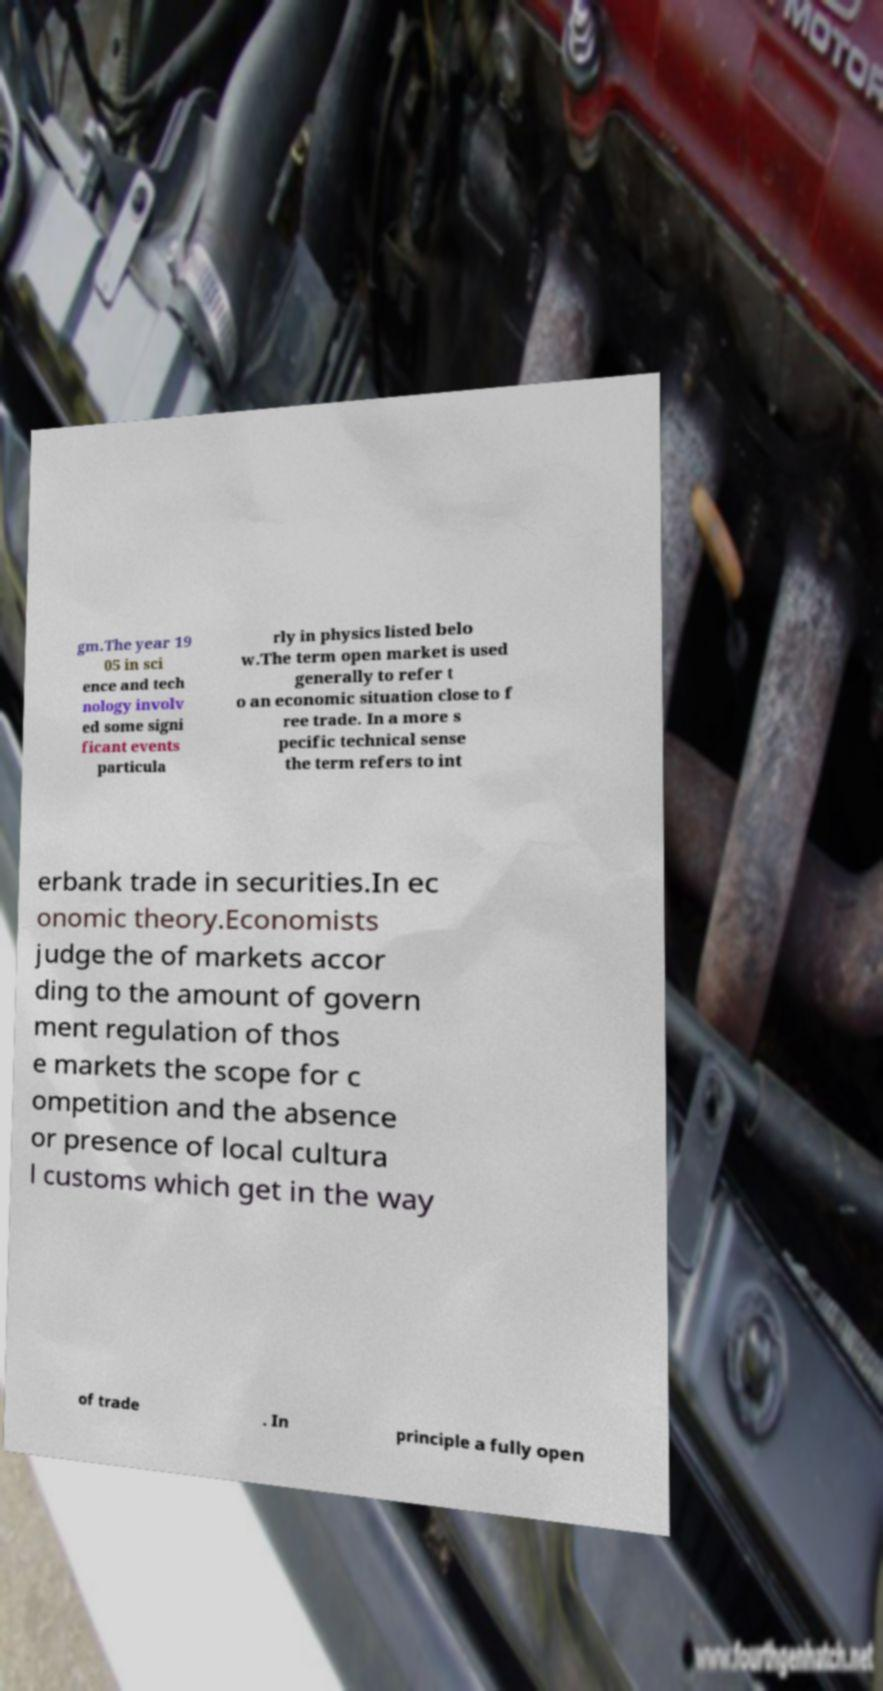There's text embedded in this image that I need extracted. Can you transcribe it verbatim? gm.The year 19 05 in sci ence and tech nology involv ed some signi ficant events particula rly in physics listed belo w.The term open market is used generally to refer t o an economic situation close to f ree trade. In a more s pecific technical sense the term refers to int erbank trade in securities.In ec onomic theory.Economists judge the of markets accor ding to the amount of govern ment regulation of thos e markets the scope for c ompetition and the absence or presence of local cultura l customs which get in the way of trade . In principle a fully open 